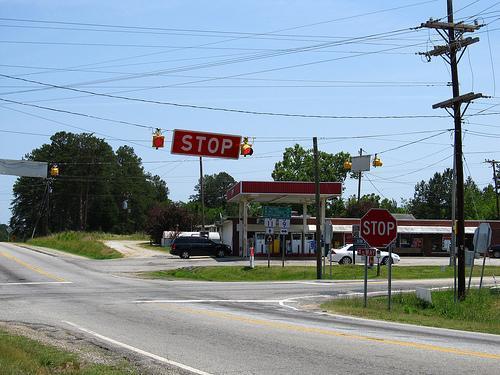How many cars are in the image?
Give a very brief answer. 2. 